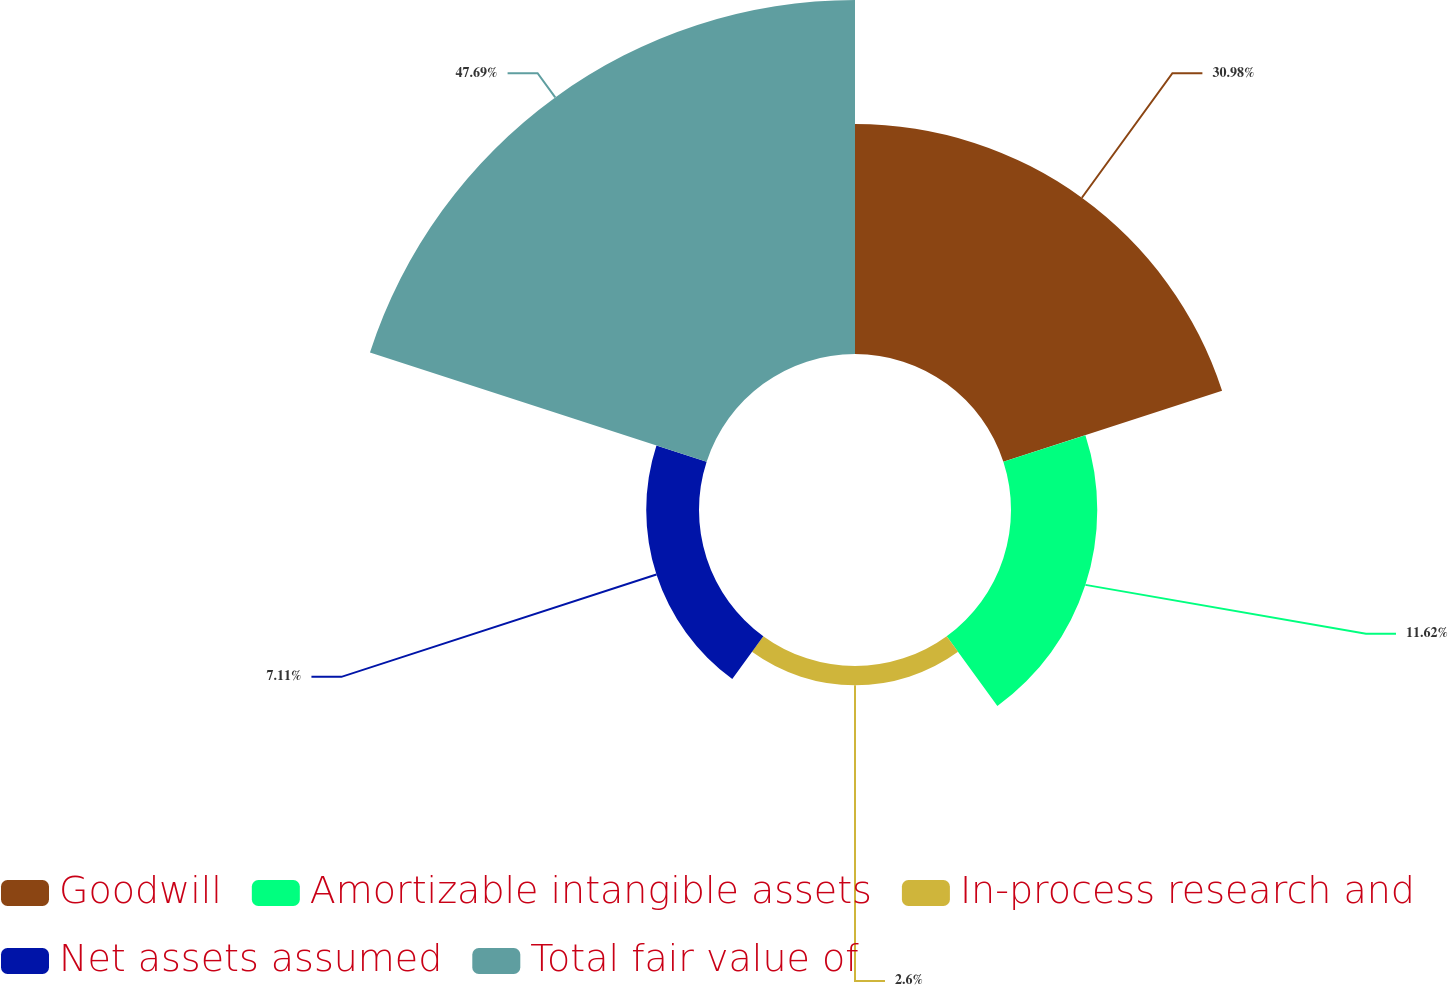Convert chart. <chart><loc_0><loc_0><loc_500><loc_500><pie_chart><fcel>Goodwill<fcel>Amortizable intangible assets<fcel>In-process research and<fcel>Net assets assumed<fcel>Total fair value of<nl><fcel>30.98%<fcel>11.62%<fcel>2.6%<fcel>7.11%<fcel>47.69%<nl></chart> 